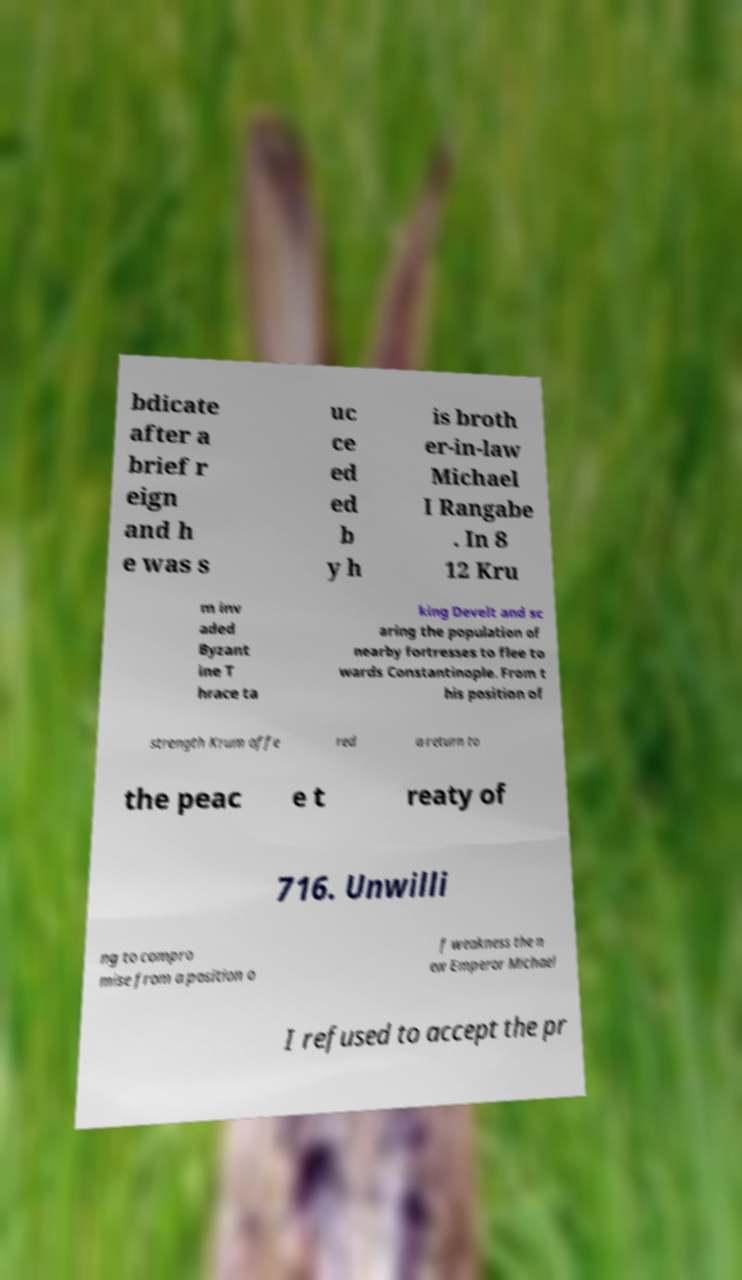For documentation purposes, I need the text within this image transcribed. Could you provide that? bdicate after a brief r eign and h e was s uc ce ed ed b y h is broth er-in-law Michael I Rangabe . In 8 12 Kru m inv aded Byzant ine T hrace ta king Develt and sc aring the population of nearby fortresses to flee to wards Constantinople. From t his position of strength Krum offe red a return to the peac e t reaty of 716. Unwilli ng to compro mise from a position o f weakness the n ew Emperor Michael I refused to accept the pr 